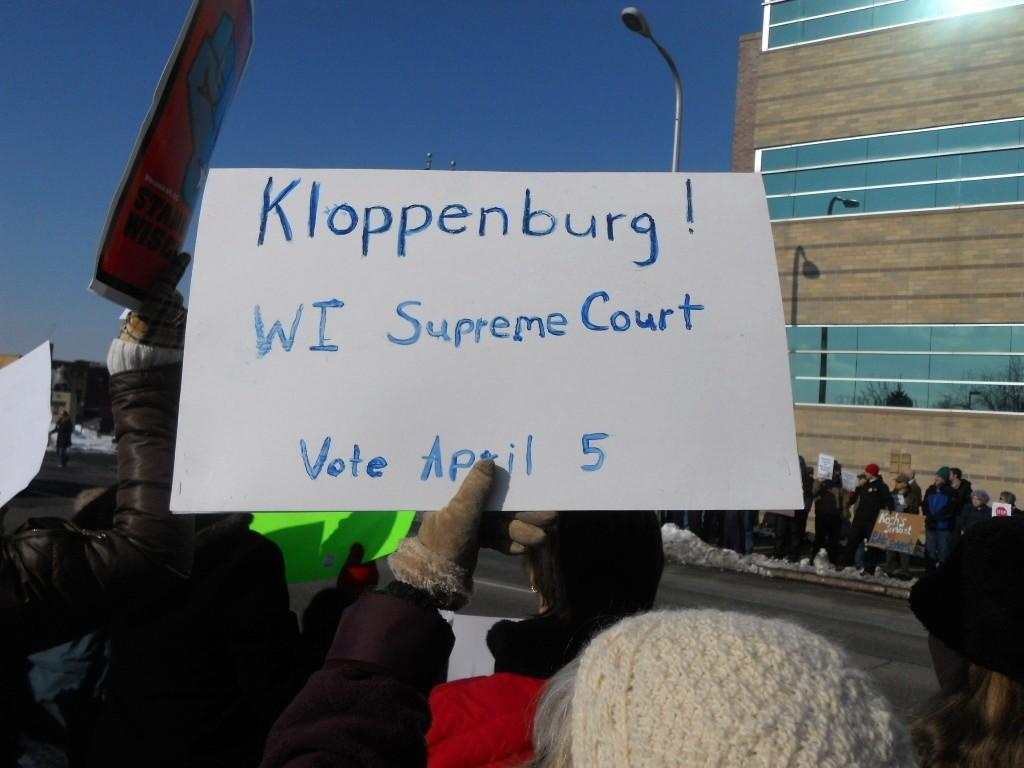What are the people in the image holding? The people in the image are holding boards with text. What can be seen in the background of the image? There is a pole and a building with glass in the background. What is visible on the ground in the image? The ground is visible in the image. What is visible in the sky in the image? The sky is visible in the image. What type of drink is being served at the shop in the image? There is no shop present in the image, and therefore no drinks are being served. Can you tell me what the uncle is doing in the image? There is no uncle or any indication of a family member in the image. 